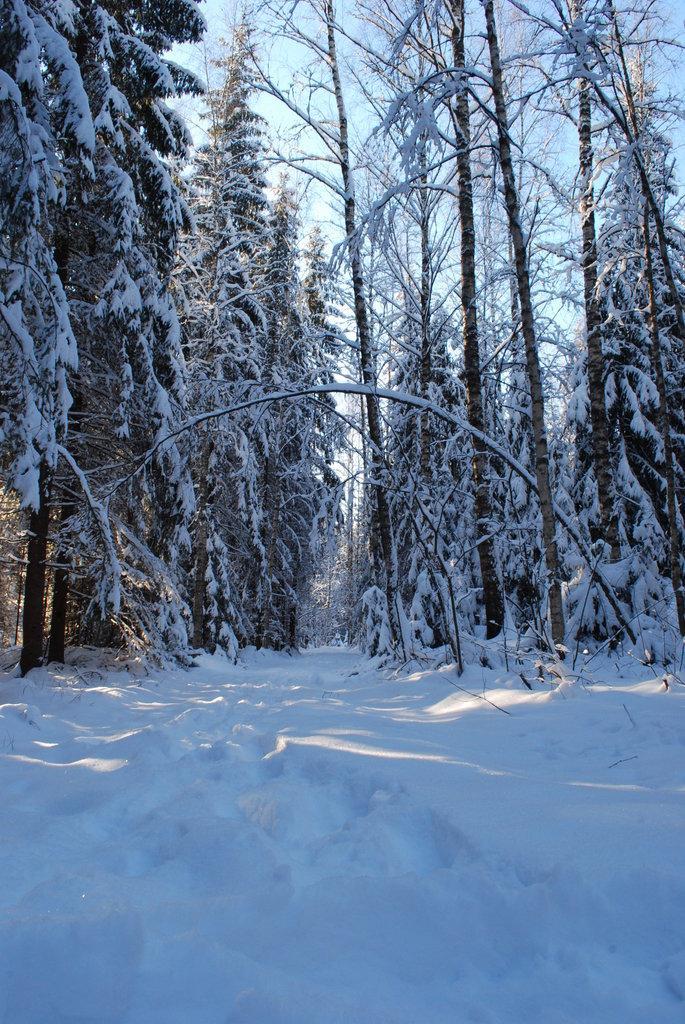Can you describe this image briefly? In this image, we can see snow on the ground, there are some trees, we can see snow on the trees, at the top there is a sky. 